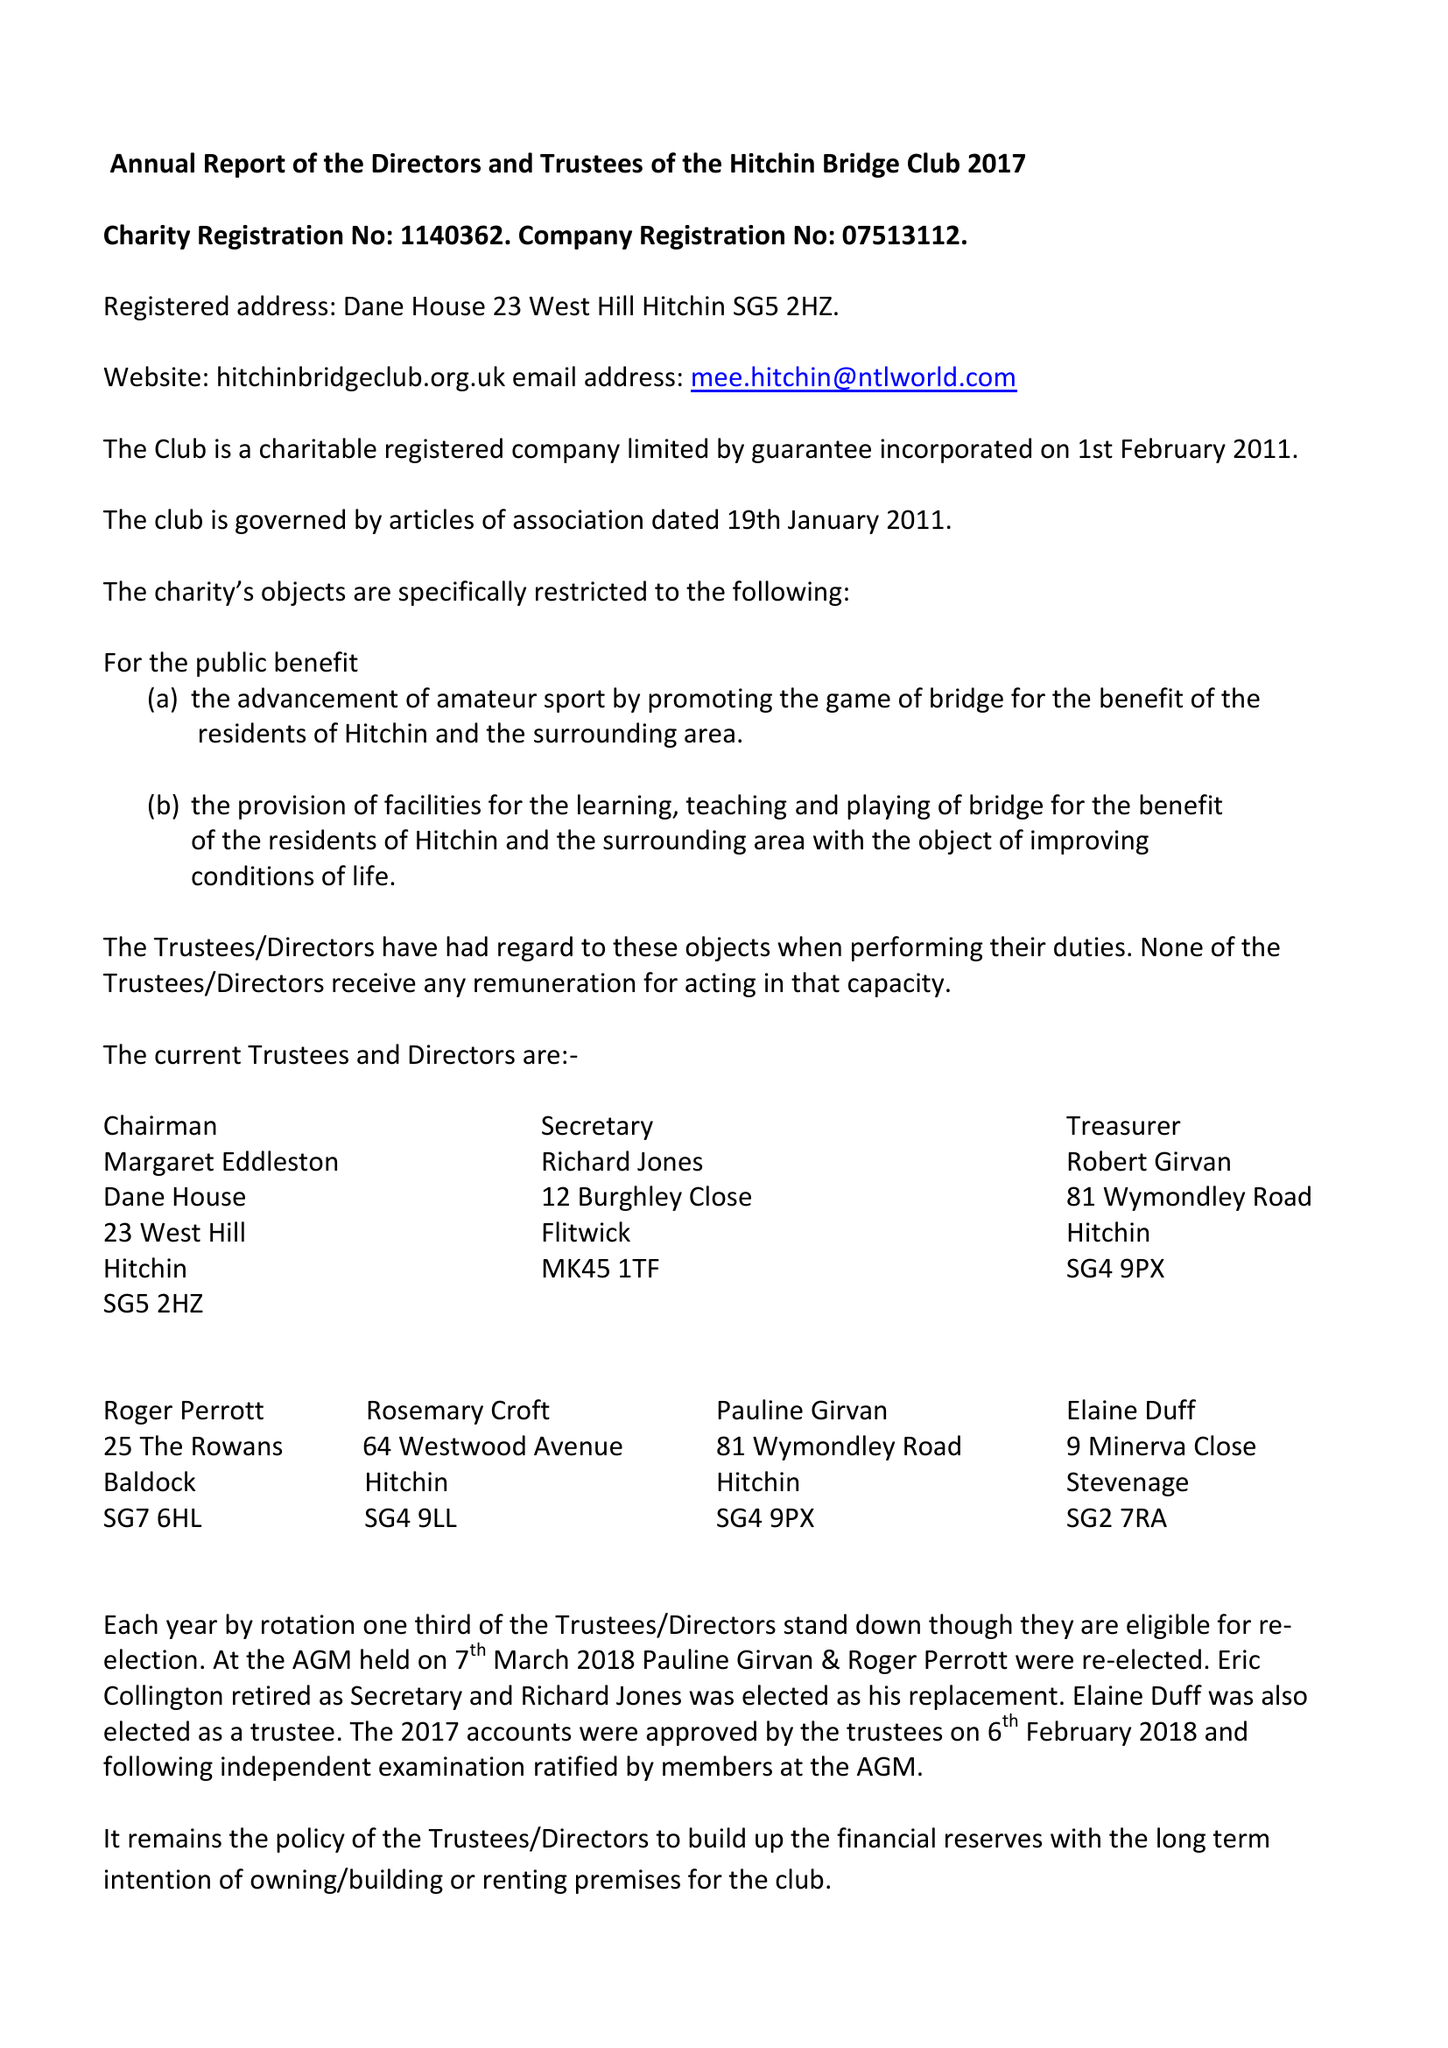What is the value for the charity_number?
Answer the question using a single word or phrase. 1140362 